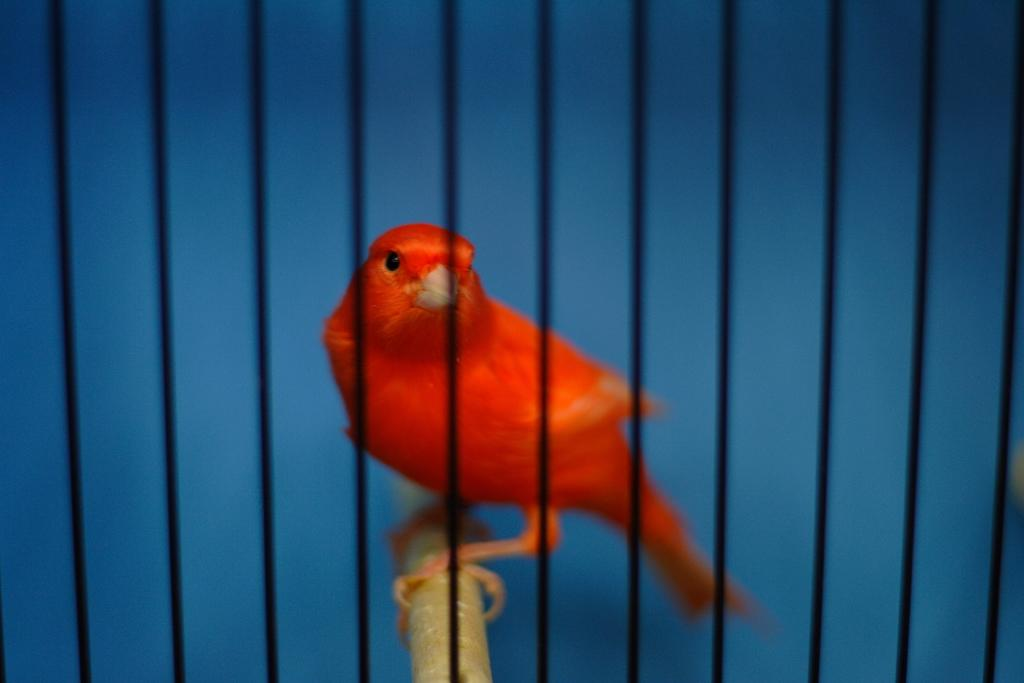What can be seen in the image related to cooking or food preparation? There are grills in the image. What other living creature is present in the image besides the grills? A bird is present on a wooden surface behind the grills. What color is predominant in the background of the image? The background of the image is blue. How many chairs are visible in the image? There are no chairs present in the image. What type of camera is being used to take the picture? There is no camera visible in the image, as we are looking at the image directly. 